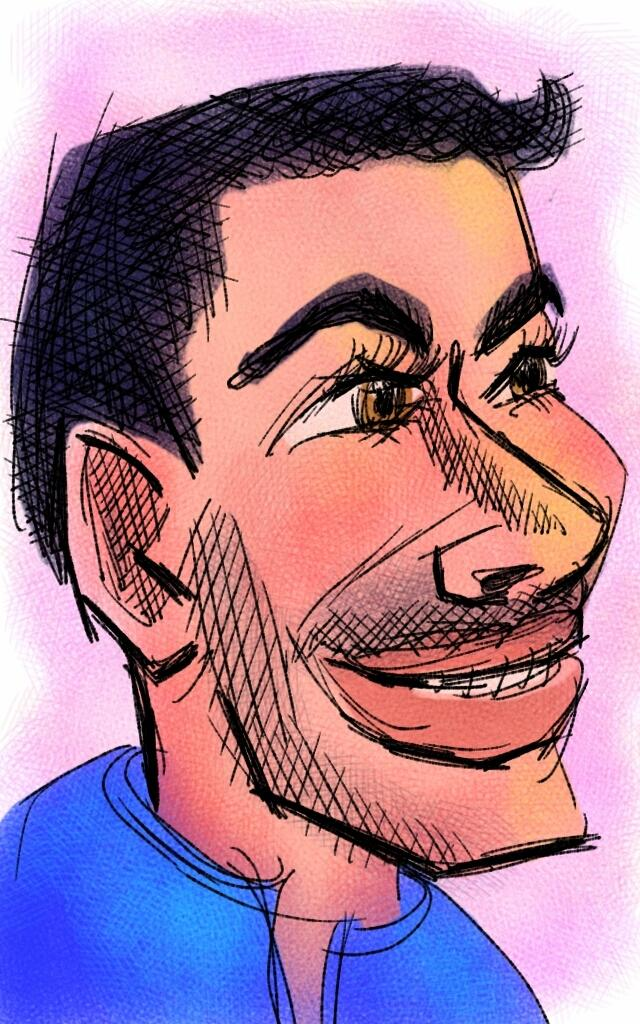What is depicted in the image? There is a sketch of a man in the image. What is the man wearing in the sketch? The man is wearing a blue t-shirt. What type of teaching method is being demonstrated in the image? There is no teaching method or any indication of teaching in the image; it is a sketch of a man wearing a blue t-shirt. 